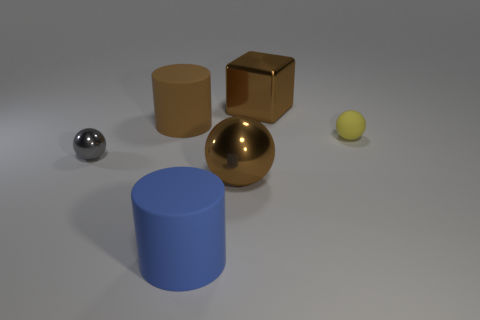Subtract all gray balls. How many balls are left? 2 Add 2 brown cylinders. How many objects exist? 8 Subtract all blocks. How many objects are left? 5 Add 2 big brown objects. How many big brown objects are left? 5 Add 2 big brown metallic things. How many big brown metallic things exist? 4 Subtract 0 gray blocks. How many objects are left? 6 Subtract all big brown spheres. Subtract all metallic spheres. How many objects are left? 3 